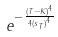<formula> <loc_0><loc_0><loc_500><loc_500>e ^ { - \frac { ( T - K ) ^ { 4 } } { 4 { ( s _ { T } ) } ^ { 4 } } }</formula> 